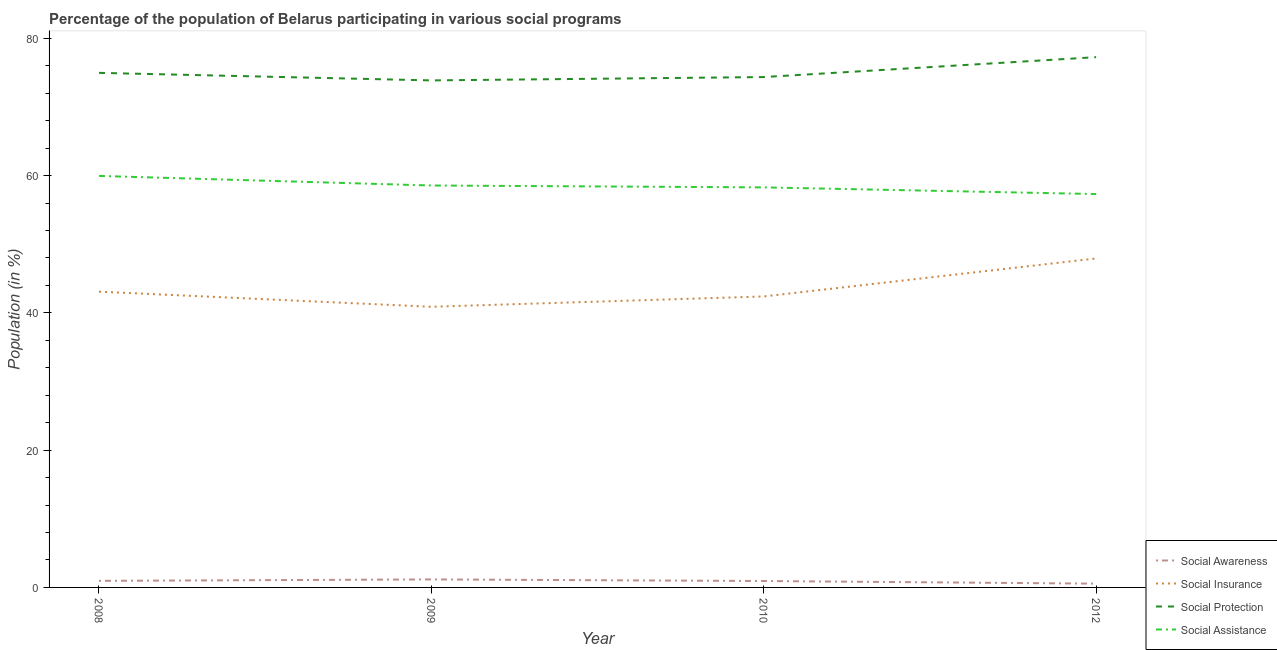How many different coloured lines are there?
Your answer should be very brief. 4. Does the line corresponding to participation of population in social protection programs intersect with the line corresponding to participation of population in social insurance programs?
Your response must be concise. No. Is the number of lines equal to the number of legend labels?
Offer a terse response. Yes. What is the participation of population in social awareness programs in 2010?
Keep it short and to the point. 0.93. Across all years, what is the maximum participation of population in social insurance programs?
Give a very brief answer. 47.93. Across all years, what is the minimum participation of population in social insurance programs?
Keep it short and to the point. 40.89. In which year was the participation of population in social assistance programs maximum?
Provide a short and direct response. 2008. In which year was the participation of population in social protection programs minimum?
Offer a terse response. 2009. What is the total participation of population in social awareness programs in the graph?
Make the answer very short. 3.61. What is the difference between the participation of population in social insurance programs in 2008 and that in 2012?
Keep it short and to the point. -4.84. What is the difference between the participation of population in social protection programs in 2012 and the participation of population in social awareness programs in 2008?
Your response must be concise. 76.29. What is the average participation of population in social assistance programs per year?
Your answer should be compact. 58.52. In the year 2008, what is the difference between the participation of population in social protection programs and participation of population in social awareness programs?
Keep it short and to the point. 74. In how many years, is the participation of population in social assistance programs greater than 68 %?
Ensure brevity in your answer.  0. What is the ratio of the participation of population in social assistance programs in 2008 to that in 2010?
Provide a short and direct response. 1.03. Is the participation of population in social awareness programs in 2008 less than that in 2012?
Your response must be concise. No. Is the difference between the participation of population in social awareness programs in 2009 and 2012 greater than the difference between the participation of population in social protection programs in 2009 and 2012?
Provide a succinct answer. Yes. What is the difference between the highest and the second highest participation of population in social awareness programs?
Your answer should be compact. 0.21. What is the difference between the highest and the lowest participation of population in social insurance programs?
Keep it short and to the point. 7.04. Is the sum of the participation of population in social assistance programs in 2009 and 2012 greater than the maximum participation of population in social insurance programs across all years?
Offer a very short reply. Yes. Is it the case that in every year, the sum of the participation of population in social awareness programs and participation of population in social protection programs is greater than the sum of participation of population in social insurance programs and participation of population in social assistance programs?
Your answer should be very brief. No. Is it the case that in every year, the sum of the participation of population in social awareness programs and participation of population in social insurance programs is greater than the participation of population in social protection programs?
Give a very brief answer. No. Does the participation of population in social assistance programs monotonically increase over the years?
Offer a very short reply. No. Is the participation of population in social assistance programs strictly greater than the participation of population in social protection programs over the years?
Keep it short and to the point. No. How many lines are there?
Keep it short and to the point. 4. What is the difference between two consecutive major ticks on the Y-axis?
Your response must be concise. 20. Does the graph contain any zero values?
Provide a succinct answer. No. Does the graph contain grids?
Your answer should be compact. No. How many legend labels are there?
Provide a succinct answer. 4. What is the title of the graph?
Offer a terse response. Percentage of the population of Belarus participating in various social programs . Does "Services" appear as one of the legend labels in the graph?
Your answer should be compact. No. What is the Population (in %) of Social Awareness in 2008?
Your response must be concise. 0.96. What is the Population (in %) in Social Insurance in 2008?
Keep it short and to the point. 43.09. What is the Population (in %) of Social Protection in 2008?
Your response must be concise. 74.96. What is the Population (in %) in Social Assistance in 2008?
Your answer should be very brief. 59.95. What is the Population (in %) in Social Awareness in 2009?
Offer a terse response. 1.17. What is the Population (in %) in Social Insurance in 2009?
Your response must be concise. 40.89. What is the Population (in %) of Social Protection in 2009?
Give a very brief answer. 73.86. What is the Population (in %) in Social Assistance in 2009?
Your answer should be compact. 58.55. What is the Population (in %) in Social Awareness in 2010?
Give a very brief answer. 0.93. What is the Population (in %) of Social Insurance in 2010?
Provide a short and direct response. 42.39. What is the Population (in %) in Social Protection in 2010?
Provide a succinct answer. 74.35. What is the Population (in %) in Social Assistance in 2010?
Make the answer very short. 58.28. What is the Population (in %) of Social Awareness in 2012?
Your response must be concise. 0.55. What is the Population (in %) in Social Insurance in 2012?
Offer a terse response. 47.93. What is the Population (in %) in Social Protection in 2012?
Provide a succinct answer. 77.25. What is the Population (in %) in Social Assistance in 2012?
Keep it short and to the point. 57.3. Across all years, what is the maximum Population (in %) of Social Awareness?
Make the answer very short. 1.17. Across all years, what is the maximum Population (in %) of Social Insurance?
Offer a terse response. 47.93. Across all years, what is the maximum Population (in %) in Social Protection?
Provide a succinct answer. 77.25. Across all years, what is the maximum Population (in %) of Social Assistance?
Your response must be concise. 59.95. Across all years, what is the minimum Population (in %) of Social Awareness?
Your answer should be compact. 0.55. Across all years, what is the minimum Population (in %) of Social Insurance?
Offer a very short reply. 40.89. Across all years, what is the minimum Population (in %) in Social Protection?
Give a very brief answer. 73.86. Across all years, what is the minimum Population (in %) in Social Assistance?
Offer a terse response. 57.3. What is the total Population (in %) of Social Awareness in the graph?
Ensure brevity in your answer.  3.61. What is the total Population (in %) in Social Insurance in the graph?
Ensure brevity in your answer.  174.29. What is the total Population (in %) of Social Protection in the graph?
Ensure brevity in your answer.  300.42. What is the total Population (in %) in Social Assistance in the graph?
Provide a short and direct response. 234.08. What is the difference between the Population (in %) of Social Awareness in 2008 and that in 2009?
Provide a succinct answer. -0.21. What is the difference between the Population (in %) of Social Insurance in 2008 and that in 2009?
Offer a very short reply. 2.2. What is the difference between the Population (in %) in Social Protection in 2008 and that in 2009?
Keep it short and to the point. 1.1. What is the difference between the Population (in %) in Social Assistance in 2008 and that in 2009?
Provide a succinct answer. 1.4. What is the difference between the Population (in %) of Social Awareness in 2008 and that in 2010?
Give a very brief answer. 0.02. What is the difference between the Population (in %) in Social Insurance in 2008 and that in 2010?
Offer a terse response. 0.7. What is the difference between the Population (in %) of Social Protection in 2008 and that in 2010?
Ensure brevity in your answer.  0.61. What is the difference between the Population (in %) in Social Assistance in 2008 and that in 2010?
Offer a terse response. 1.67. What is the difference between the Population (in %) in Social Awareness in 2008 and that in 2012?
Offer a very short reply. 0.4. What is the difference between the Population (in %) of Social Insurance in 2008 and that in 2012?
Offer a very short reply. -4.84. What is the difference between the Population (in %) of Social Protection in 2008 and that in 2012?
Give a very brief answer. -2.29. What is the difference between the Population (in %) of Social Assistance in 2008 and that in 2012?
Provide a succinct answer. 2.64. What is the difference between the Population (in %) in Social Awareness in 2009 and that in 2010?
Provide a short and direct response. 0.23. What is the difference between the Population (in %) in Social Insurance in 2009 and that in 2010?
Give a very brief answer. -1.5. What is the difference between the Population (in %) in Social Protection in 2009 and that in 2010?
Ensure brevity in your answer.  -0.49. What is the difference between the Population (in %) in Social Assistance in 2009 and that in 2010?
Provide a short and direct response. 0.27. What is the difference between the Population (in %) of Social Awareness in 2009 and that in 2012?
Provide a succinct answer. 0.61. What is the difference between the Population (in %) of Social Insurance in 2009 and that in 2012?
Offer a terse response. -7.04. What is the difference between the Population (in %) of Social Protection in 2009 and that in 2012?
Offer a terse response. -3.39. What is the difference between the Population (in %) in Social Assistance in 2009 and that in 2012?
Provide a short and direct response. 1.25. What is the difference between the Population (in %) of Social Awareness in 2010 and that in 2012?
Your response must be concise. 0.38. What is the difference between the Population (in %) in Social Insurance in 2010 and that in 2012?
Ensure brevity in your answer.  -5.54. What is the difference between the Population (in %) in Social Protection in 2010 and that in 2012?
Offer a terse response. -2.9. What is the difference between the Population (in %) of Social Assistance in 2010 and that in 2012?
Provide a short and direct response. 0.97. What is the difference between the Population (in %) in Social Awareness in 2008 and the Population (in %) in Social Insurance in 2009?
Your response must be concise. -39.93. What is the difference between the Population (in %) in Social Awareness in 2008 and the Population (in %) in Social Protection in 2009?
Keep it short and to the point. -72.9. What is the difference between the Population (in %) of Social Awareness in 2008 and the Population (in %) of Social Assistance in 2009?
Provide a short and direct response. -57.59. What is the difference between the Population (in %) of Social Insurance in 2008 and the Population (in %) of Social Protection in 2009?
Ensure brevity in your answer.  -30.78. What is the difference between the Population (in %) in Social Insurance in 2008 and the Population (in %) in Social Assistance in 2009?
Ensure brevity in your answer.  -15.47. What is the difference between the Population (in %) of Social Protection in 2008 and the Population (in %) of Social Assistance in 2009?
Keep it short and to the point. 16.41. What is the difference between the Population (in %) of Social Awareness in 2008 and the Population (in %) of Social Insurance in 2010?
Make the answer very short. -41.43. What is the difference between the Population (in %) in Social Awareness in 2008 and the Population (in %) in Social Protection in 2010?
Your answer should be very brief. -73.39. What is the difference between the Population (in %) of Social Awareness in 2008 and the Population (in %) of Social Assistance in 2010?
Keep it short and to the point. -57.32. What is the difference between the Population (in %) of Social Insurance in 2008 and the Population (in %) of Social Protection in 2010?
Offer a terse response. -31.26. What is the difference between the Population (in %) of Social Insurance in 2008 and the Population (in %) of Social Assistance in 2010?
Offer a terse response. -15.19. What is the difference between the Population (in %) in Social Protection in 2008 and the Population (in %) in Social Assistance in 2010?
Offer a terse response. 16.68. What is the difference between the Population (in %) of Social Awareness in 2008 and the Population (in %) of Social Insurance in 2012?
Make the answer very short. -46.97. What is the difference between the Population (in %) of Social Awareness in 2008 and the Population (in %) of Social Protection in 2012?
Your response must be concise. -76.29. What is the difference between the Population (in %) of Social Awareness in 2008 and the Population (in %) of Social Assistance in 2012?
Your answer should be very brief. -56.35. What is the difference between the Population (in %) of Social Insurance in 2008 and the Population (in %) of Social Protection in 2012?
Your response must be concise. -34.16. What is the difference between the Population (in %) of Social Insurance in 2008 and the Population (in %) of Social Assistance in 2012?
Provide a succinct answer. -14.22. What is the difference between the Population (in %) of Social Protection in 2008 and the Population (in %) of Social Assistance in 2012?
Your answer should be compact. 17.66. What is the difference between the Population (in %) of Social Awareness in 2009 and the Population (in %) of Social Insurance in 2010?
Your answer should be very brief. -41.22. What is the difference between the Population (in %) of Social Awareness in 2009 and the Population (in %) of Social Protection in 2010?
Offer a very short reply. -73.18. What is the difference between the Population (in %) in Social Awareness in 2009 and the Population (in %) in Social Assistance in 2010?
Your response must be concise. -57.11. What is the difference between the Population (in %) of Social Insurance in 2009 and the Population (in %) of Social Protection in 2010?
Keep it short and to the point. -33.47. What is the difference between the Population (in %) in Social Insurance in 2009 and the Population (in %) in Social Assistance in 2010?
Give a very brief answer. -17.39. What is the difference between the Population (in %) of Social Protection in 2009 and the Population (in %) of Social Assistance in 2010?
Your answer should be very brief. 15.58. What is the difference between the Population (in %) in Social Awareness in 2009 and the Population (in %) in Social Insurance in 2012?
Your answer should be very brief. -46.76. What is the difference between the Population (in %) of Social Awareness in 2009 and the Population (in %) of Social Protection in 2012?
Ensure brevity in your answer.  -76.08. What is the difference between the Population (in %) in Social Awareness in 2009 and the Population (in %) in Social Assistance in 2012?
Make the answer very short. -56.14. What is the difference between the Population (in %) in Social Insurance in 2009 and the Population (in %) in Social Protection in 2012?
Offer a very short reply. -36.37. What is the difference between the Population (in %) in Social Insurance in 2009 and the Population (in %) in Social Assistance in 2012?
Your answer should be very brief. -16.42. What is the difference between the Population (in %) of Social Protection in 2009 and the Population (in %) of Social Assistance in 2012?
Offer a terse response. 16.56. What is the difference between the Population (in %) in Social Awareness in 2010 and the Population (in %) in Social Insurance in 2012?
Ensure brevity in your answer.  -46.99. What is the difference between the Population (in %) in Social Awareness in 2010 and the Population (in %) in Social Protection in 2012?
Your response must be concise. -76.32. What is the difference between the Population (in %) in Social Awareness in 2010 and the Population (in %) in Social Assistance in 2012?
Your response must be concise. -56.37. What is the difference between the Population (in %) in Social Insurance in 2010 and the Population (in %) in Social Protection in 2012?
Your answer should be compact. -34.86. What is the difference between the Population (in %) of Social Insurance in 2010 and the Population (in %) of Social Assistance in 2012?
Offer a terse response. -14.92. What is the difference between the Population (in %) of Social Protection in 2010 and the Population (in %) of Social Assistance in 2012?
Your answer should be compact. 17.05. What is the average Population (in %) in Social Awareness per year?
Your response must be concise. 0.9. What is the average Population (in %) in Social Insurance per year?
Provide a short and direct response. 43.57. What is the average Population (in %) in Social Protection per year?
Your response must be concise. 75.11. What is the average Population (in %) of Social Assistance per year?
Your answer should be very brief. 58.52. In the year 2008, what is the difference between the Population (in %) in Social Awareness and Population (in %) in Social Insurance?
Offer a terse response. -42.13. In the year 2008, what is the difference between the Population (in %) in Social Awareness and Population (in %) in Social Protection?
Your answer should be compact. -74. In the year 2008, what is the difference between the Population (in %) of Social Awareness and Population (in %) of Social Assistance?
Ensure brevity in your answer.  -58.99. In the year 2008, what is the difference between the Population (in %) in Social Insurance and Population (in %) in Social Protection?
Offer a terse response. -31.88. In the year 2008, what is the difference between the Population (in %) of Social Insurance and Population (in %) of Social Assistance?
Make the answer very short. -16.86. In the year 2008, what is the difference between the Population (in %) in Social Protection and Population (in %) in Social Assistance?
Your answer should be very brief. 15.01. In the year 2009, what is the difference between the Population (in %) of Social Awareness and Population (in %) of Social Insurance?
Make the answer very short. -39.72. In the year 2009, what is the difference between the Population (in %) of Social Awareness and Population (in %) of Social Protection?
Ensure brevity in your answer.  -72.7. In the year 2009, what is the difference between the Population (in %) in Social Awareness and Population (in %) in Social Assistance?
Your answer should be compact. -57.39. In the year 2009, what is the difference between the Population (in %) of Social Insurance and Population (in %) of Social Protection?
Offer a terse response. -32.98. In the year 2009, what is the difference between the Population (in %) in Social Insurance and Population (in %) in Social Assistance?
Your response must be concise. -17.67. In the year 2009, what is the difference between the Population (in %) in Social Protection and Population (in %) in Social Assistance?
Provide a succinct answer. 15.31. In the year 2010, what is the difference between the Population (in %) in Social Awareness and Population (in %) in Social Insurance?
Ensure brevity in your answer.  -41.46. In the year 2010, what is the difference between the Population (in %) of Social Awareness and Population (in %) of Social Protection?
Keep it short and to the point. -73.42. In the year 2010, what is the difference between the Population (in %) in Social Awareness and Population (in %) in Social Assistance?
Make the answer very short. -57.34. In the year 2010, what is the difference between the Population (in %) in Social Insurance and Population (in %) in Social Protection?
Provide a succinct answer. -31.96. In the year 2010, what is the difference between the Population (in %) of Social Insurance and Population (in %) of Social Assistance?
Your answer should be compact. -15.89. In the year 2010, what is the difference between the Population (in %) in Social Protection and Population (in %) in Social Assistance?
Give a very brief answer. 16.07. In the year 2012, what is the difference between the Population (in %) of Social Awareness and Population (in %) of Social Insurance?
Give a very brief answer. -47.37. In the year 2012, what is the difference between the Population (in %) in Social Awareness and Population (in %) in Social Protection?
Offer a terse response. -76.7. In the year 2012, what is the difference between the Population (in %) in Social Awareness and Population (in %) in Social Assistance?
Offer a terse response. -56.75. In the year 2012, what is the difference between the Population (in %) in Social Insurance and Population (in %) in Social Protection?
Ensure brevity in your answer.  -29.32. In the year 2012, what is the difference between the Population (in %) in Social Insurance and Population (in %) in Social Assistance?
Your answer should be compact. -9.38. In the year 2012, what is the difference between the Population (in %) of Social Protection and Population (in %) of Social Assistance?
Provide a short and direct response. 19.95. What is the ratio of the Population (in %) of Social Awareness in 2008 to that in 2009?
Offer a terse response. 0.82. What is the ratio of the Population (in %) in Social Insurance in 2008 to that in 2009?
Your response must be concise. 1.05. What is the ratio of the Population (in %) in Social Protection in 2008 to that in 2009?
Make the answer very short. 1.01. What is the ratio of the Population (in %) of Social Assistance in 2008 to that in 2009?
Keep it short and to the point. 1.02. What is the ratio of the Population (in %) in Social Awareness in 2008 to that in 2010?
Make the answer very short. 1.02. What is the ratio of the Population (in %) of Social Insurance in 2008 to that in 2010?
Provide a succinct answer. 1.02. What is the ratio of the Population (in %) of Social Protection in 2008 to that in 2010?
Provide a short and direct response. 1.01. What is the ratio of the Population (in %) in Social Assistance in 2008 to that in 2010?
Your answer should be very brief. 1.03. What is the ratio of the Population (in %) of Social Awareness in 2008 to that in 2012?
Your answer should be compact. 1.73. What is the ratio of the Population (in %) of Social Insurance in 2008 to that in 2012?
Provide a short and direct response. 0.9. What is the ratio of the Population (in %) in Social Protection in 2008 to that in 2012?
Your answer should be compact. 0.97. What is the ratio of the Population (in %) of Social Assistance in 2008 to that in 2012?
Offer a terse response. 1.05. What is the ratio of the Population (in %) in Social Awareness in 2009 to that in 2010?
Make the answer very short. 1.25. What is the ratio of the Population (in %) of Social Insurance in 2009 to that in 2010?
Ensure brevity in your answer.  0.96. What is the ratio of the Population (in %) of Social Protection in 2009 to that in 2010?
Give a very brief answer. 0.99. What is the ratio of the Population (in %) in Social Awareness in 2009 to that in 2012?
Offer a terse response. 2.11. What is the ratio of the Population (in %) in Social Insurance in 2009 to that in 2012?
Ensure brevity in your answer.  0.85. What is the ratio of the Population (in %) of Social Protection in 2009 to that in 2012?
Make the answer very short. 0.96. What is the ratio of the Population (in %) of Social Assistance in 2009 to that in 2012?
Provide a succinct answer. 1.02. What is the ratio of the Population (in %) in Social Awareness in 2010 to that in 2012?
Ensure brevity in your answer.  1.69. What is the ratio of the Population (in %) in Social Insurance in 2010 to that in 2012?
Ensure brevity in your answer.  0.88. What is the ratio of the Population (in %) in Social Protection in 2010 to that in 2012?
Provide a succinct answer. 0.96. What is the difference between the highest and the second highest Population (in %) of Social Awareness?
Provide a short and direct response. 0.21. What is the difference between the highest and the second highest Population (in %) of Social Insurance?
Your answer should be compact. 4.84. What is the difference between the highest and the second highest Population (in %) of Social Protection?
Your answer should be compact. 2.29. What is the difference between the highest and the second highest Population (in %) of Social Assistance?
Your response must be concise. 1.4. What is the difference between the highest and the lowest Population (in %) of Social Awareness?
Your response must be concise. 0.61. What is the difference between the highest and the lowest Population (in %) in Social Insurance?
Make the answer very short. 7.04. What is the difference between the highest and the lowest Population (in %) of Social Protection?
Provide a short and direct response. 3.39. What is the difference between the highest and the lowest Population (in %) in Social Assistance?
Your answer should be compact. 2.64. 